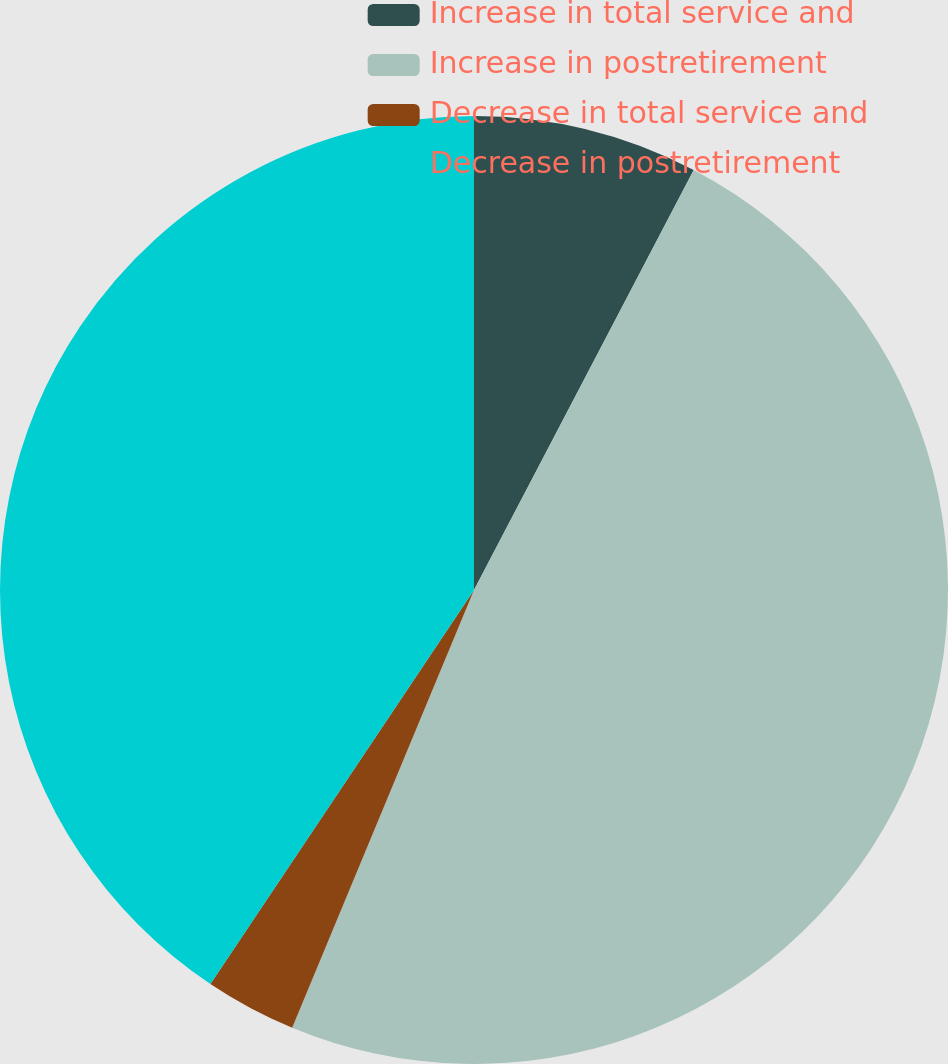<chart> <loc_0><loc_0><loc_500><loc_500><pie_chart><fcel>Increase in total service and<fcel>Increase in postretirement<fcel>Decrease in total service and<fcel>Decrease in postretirement<nl><fcel>7.67%<fcel>48.59%<fcel>3.12%<fcel>40.61%<nl></chart> 